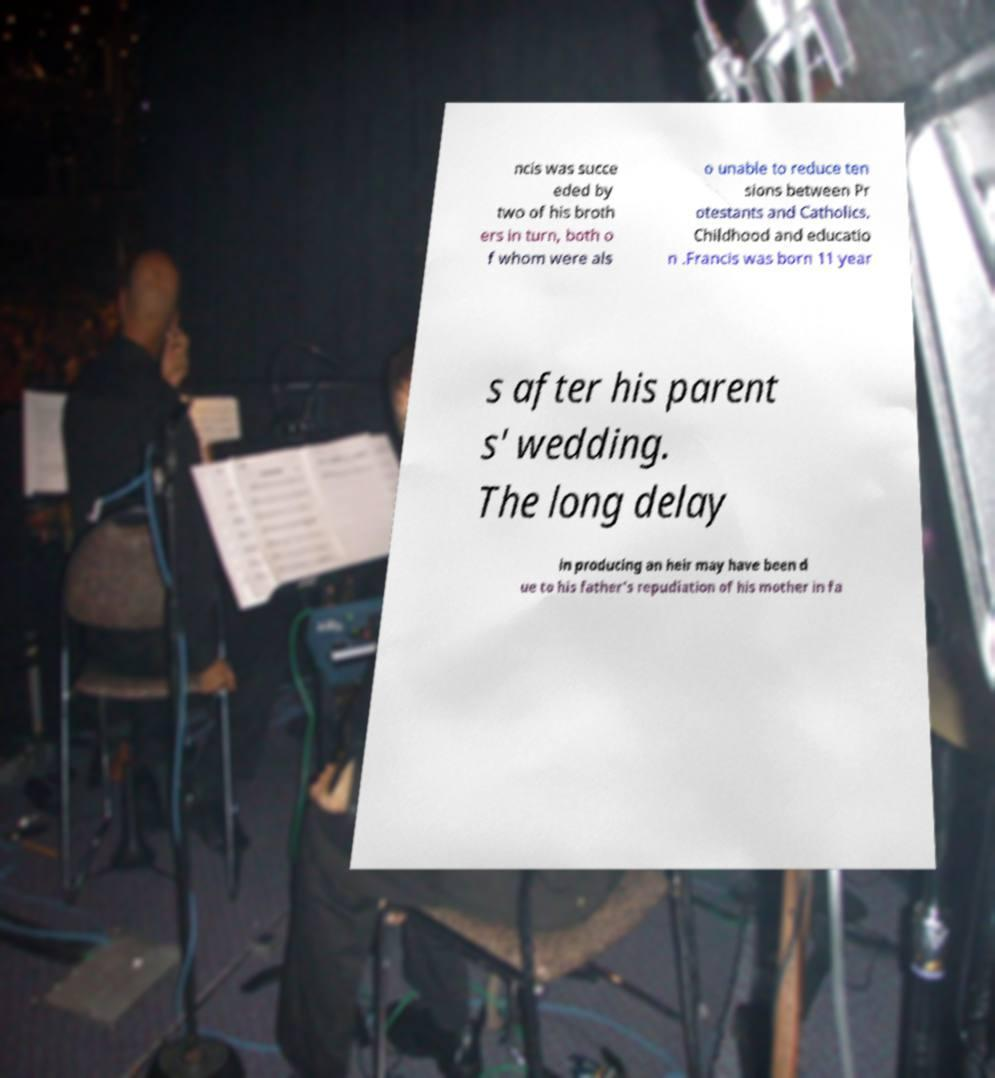For documentation purposes, I need the text within this image transcribed. Could you provide that? ncis was succe eded by two of his broth ers in turn, both o f whom were als o unable to reduce ten sions between Pr otestants and Catholics. Childhood and educatio n .Francis was born 11 year s after his parent s' wedding. The long delay in producing an heir may have been d ue to his father's repudiation of his mother in fa 